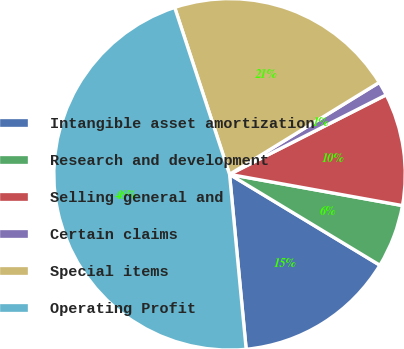<chart> <loc_0><loc_0><loc_500><loc_500><pie_chart><fcel>Intangible asset amortization<fcel>Research and development<fcel>Selling general and<fcel>Certain claims<fcel>Special items<fcel>Operating Profit<nl><fcel>14.84%<fcel>5.81%<fcel>10.32%<fcel>1.29%<fcel>21.29%<fcel>46.45%<nl></chart> 